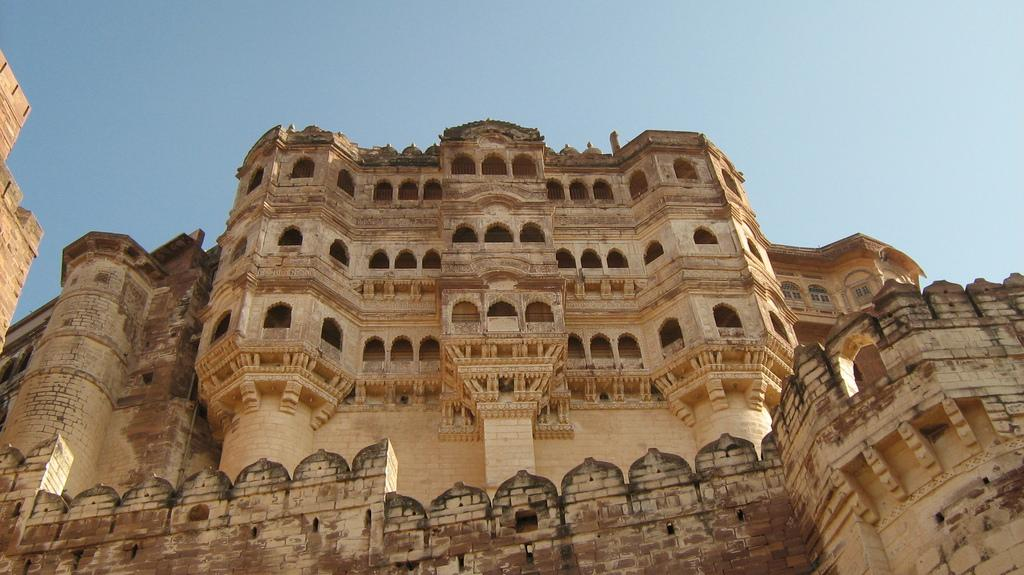What type of structures are visible in the image? There are buildings in the image. What material are the buildings made of? The buildings are made up of stone bricks. What is the condition of the sky in the image? The sky is clear in the image. Can you tell me how many tents are set up in the scene? There is no mention of tents in the image; the image features buildings made of stone bricks. What type of guide is present in the scene to help visitors navigate the area? There is no guide present in the image; the image only shows buildings and a clear sky. 